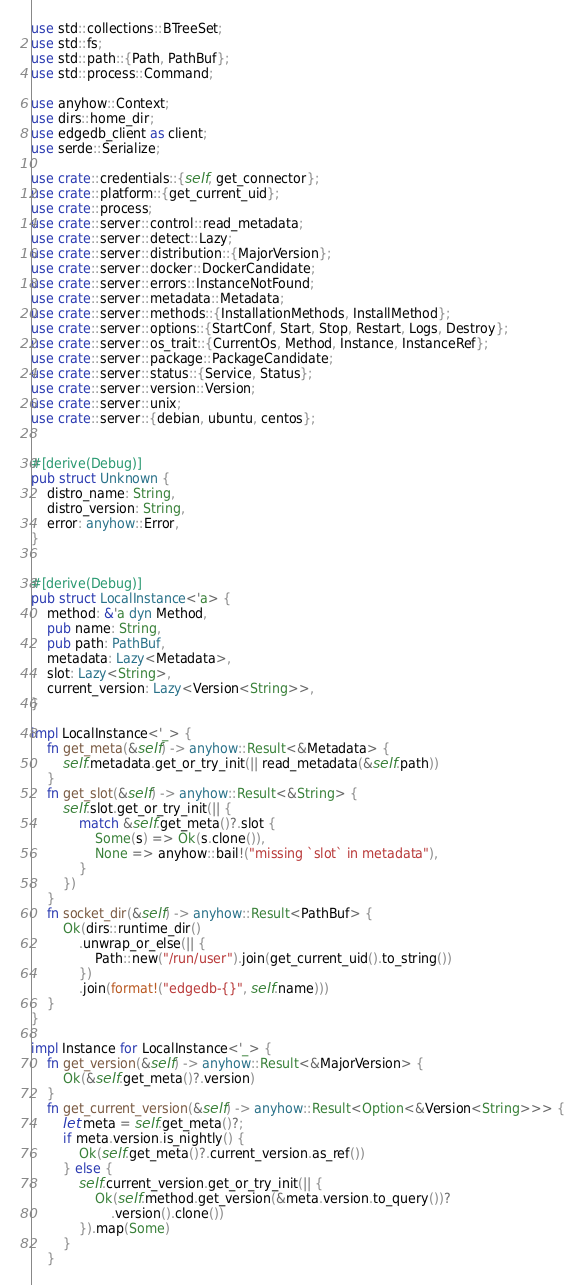<code> <loc_0><loc_0><loc_500><loc_500><_Rust_>use std::collections::BTreeSet;
use std::fs;
use std::path::{Path, PathBuf};
use std::process::Command;

use anyhow::Context;
use dirs::home_dir;
use edgedb_client as client;
use serde::Serialize;

use crate::credentials::{self, get_connector};
use crate::platform::{get_current_uid};
use crate::process;
use crate::server::control::read_metadata;
use crate::server::detect::Lazy;
use crate::server::distribution::{MajorVersion};
use crate::server::docker::DockerCandidate;
use crate::server::errors::InstanceNotFound;
use crate::server::metadata::Metadata;
use crate::server::methods::{InstallationMethods, InstallMethod};
use crate::server::options::{StartConf, Start, Stop, Restart, Logs, Destroy};
use crate::server::os_trait::{CurrentOs, Method, Instance, InstanceRef};
use crate::server::package::PackageCandidate;
use crate::server::status::{Service, Status};
use crate::server::version::Version;
use crate::server::unix;
use crate::server::{debian, ubuntu, centos};


#[derive(Debug)]
pub struct Unknown {
    distro_name: String,
    distro_version: String,
    error: anyhow::Error,
}


#[derive(Debug)]
pub struct LocalInstance<'a> {
    method: &'a dyn Method,
    pub name: String,
    pub path: PathBuf,
    metadata: Lazy<Metadata>,
    slot: Lazy<String>,
    current_version: Lazy<Version<String>>,
}

impl LocalInstance<'_> {
    fn get_meta(&self) -> anyhow::Result<&Metadata> {
        self.metadata.get_or_try_init(|| read_metadata(&self.path))
    }
    fn get_slot(&self) -> anyhow::Result<&String> {
        self.slot.get_or_try_init(|| {
            match &self.get_meta()?.slot {
                Some(s) => Ok(s.clone()),
                None => anyhow::bail!("missing `slot` in metadata"),
            }
        })
    }
    fn socket_dir(&self) -> anyhow::Result<PathBuf> {
        Ok(dirs::runtime_dir()
            .unwrap_or_else(|| {
                Path::new("/run/user").join(get_current_uid().to_string())
            })
            .join(format!("edgedb-{}", self.name)))
    }
}

impl Instance for LocalInstance<'_> {
    fn get_version(&self) -> anyhow::Result<&MajorVersion> {
        Ok(&self.get_meta()?.version)
    }
    fn get_current_version(&self) -> anyhow::Result<Option<&Version<String>>> {
        let meta = self.get_meta()?;
        if meta.version.is_nightly() {
            Ok(self.get_meta()?.current_version.as_ref())
        } else {
            self.current_version.get_or_try_init(|| {
                Ok(self.method.get_version(&meta.version.to_query())?
                    .version().clone())
            }).map(Some)
        }
    }</code> 